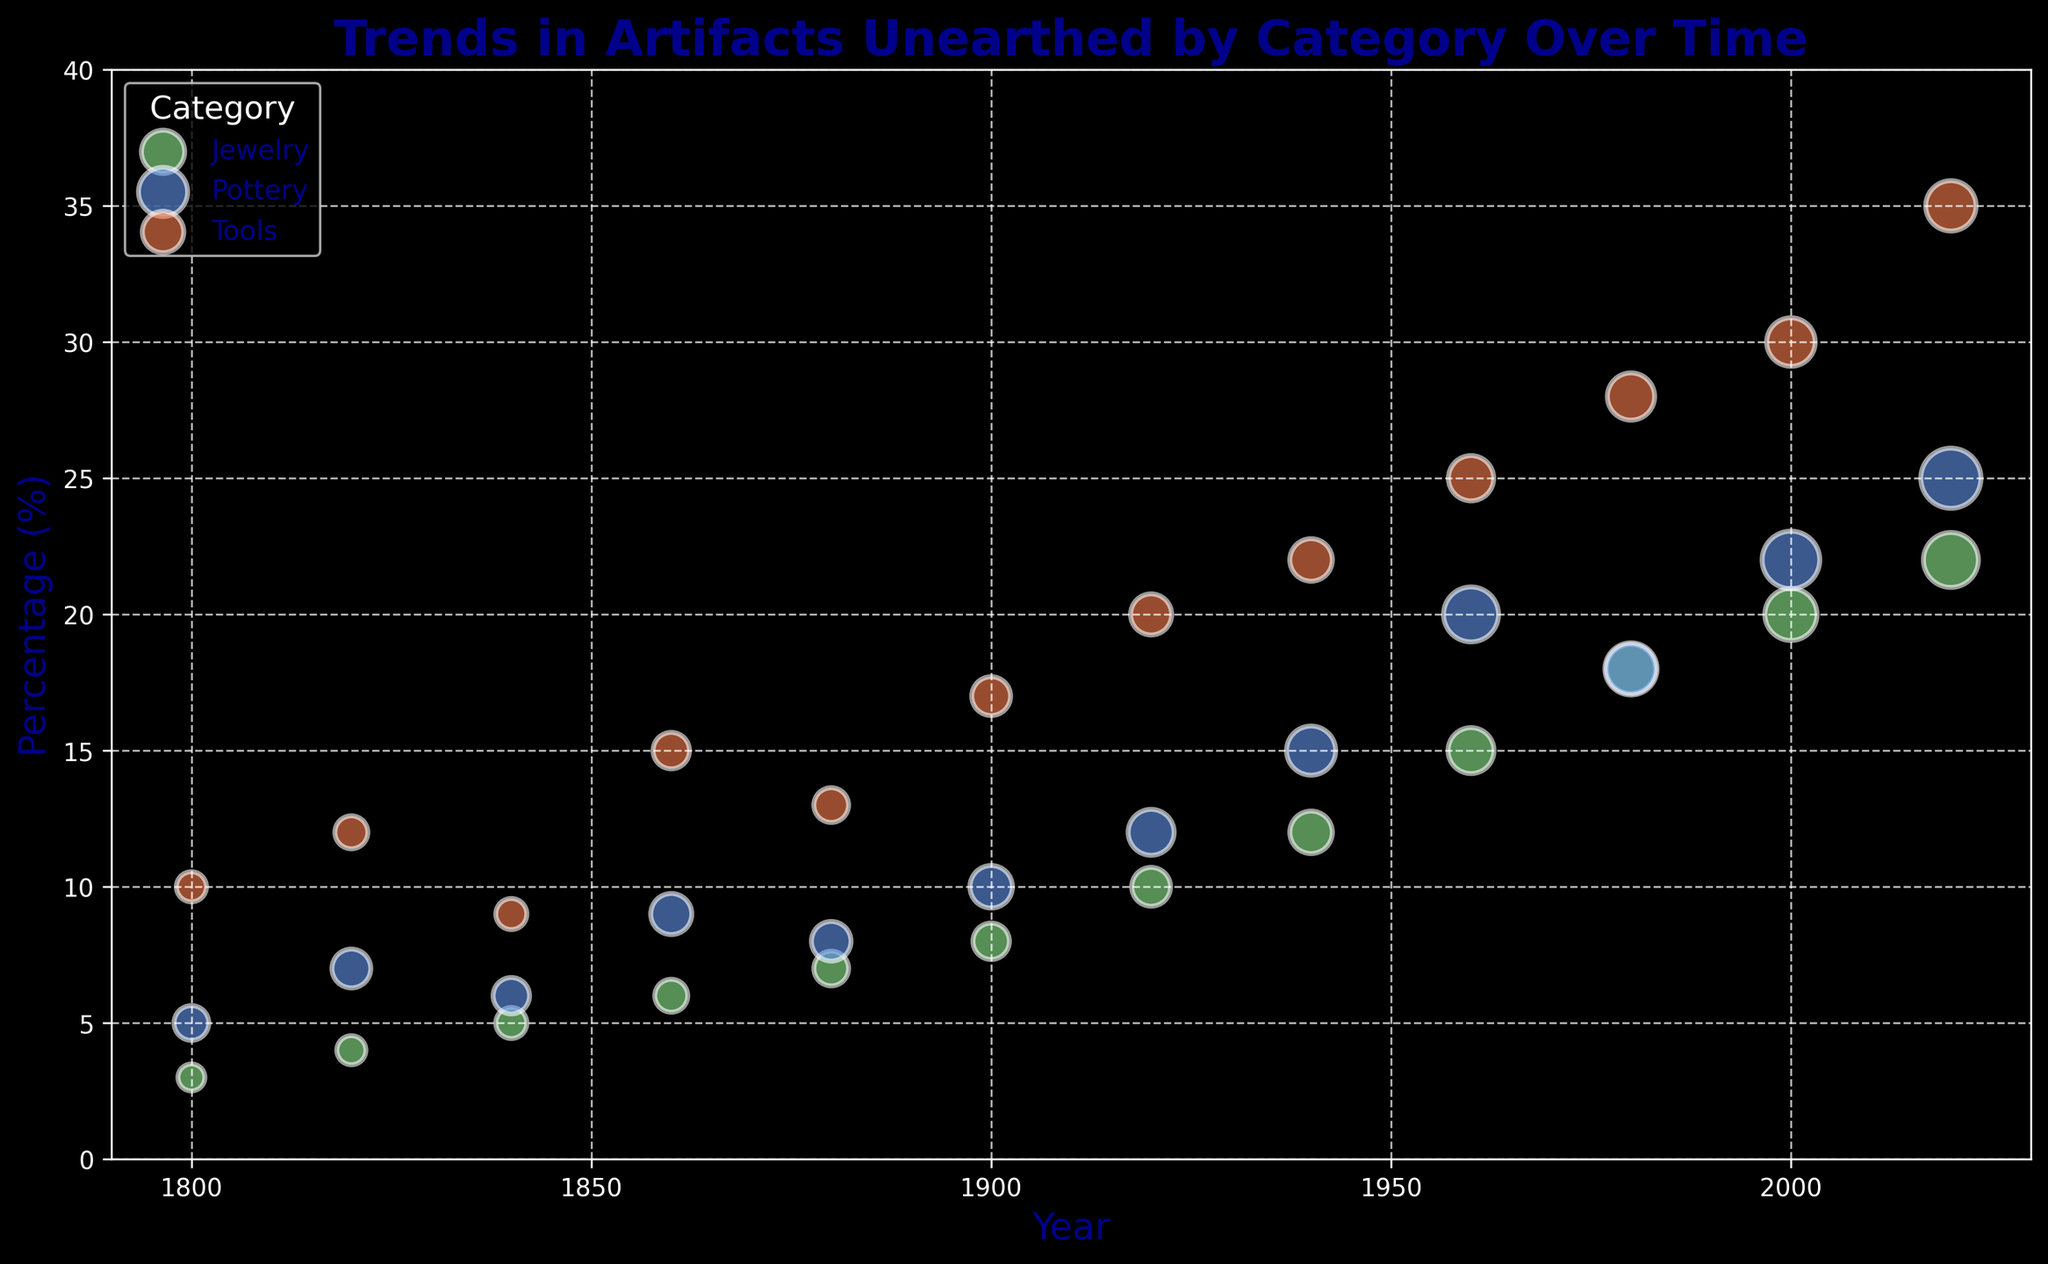What is the percentage increase in the unearthing of Pottery from 1800 to 2020? To find the percentage increase, subtract the initial value (5% in 1800) from the final value (25% in 2020), then divide the result by the initial value and multiply by 100. (25 - 5) / 5 * 100 = 400%
Answer: 400% Which artifact category showed the largest increase in unearthed percentage from 1800 to 2020? Compare the percentage increase for each category from 1800 to 2020:
- Pottery: (25 - 5) = 20%
- Tools: (35 - 10) = 25%
- Jewelry: (22 - 3) = 19%
Tools showed the largest increase.
Answer: Tools What was the percentage of Tools unearthed in 2000? Look for the data point corresponding to Tools in the year 2000, which is at 30%.
Answer: 30% Between 1900 and 1960, which category had the most significant increase in the size of unearthed artifacts? Compare the sizes in 1900 and 1960 for each category:
- Pottery: 50 - 30 = 20
- Tools: 34 - 25 = 9
- Jewelry: 35 - 22 = 13
Pottery had the most significant increase in size.
Answer: Pottery What is the average percentage of Jewelry unearthed from 1800 to 2020? Sum all the percentages of Jewelry unearthed from 1800 to 2020 (3 + 4 + 5 + 6 + 7 + 8 + 10 + 12 + 15 + 18 + 20 + 22 = 130), then divide by the number of data points (12). 130 / 12 ≈ 10.83%
Answer: 10.83% What trend can be observed in the unearthing of Pottery over time? The percentage of Pottery unearthed shows a general increase from 1800 (5%) to 2020 (25%), with some fluctuations but an overall upward trend. The size of the unearthed artifacts also increases.
Answer: General Increase How does the size of unearthed Tools in 2020 compare to the size of unearthed Jewelry in 2020? Compare the sizes in 2020:
- Tools: 42
- Jewelry: 50
Jewelry unearthed in 2020 is larger in size than Tools.
Answer: Jewelry Which category had the highest percentage of unearthed artifacts in 1960? Look at the percentages for each category in 1960:
- Pottery: 20%
- Tools: 25%
- Jewelry: 15%
Tools had the highest percentage.
Answer: Tools 